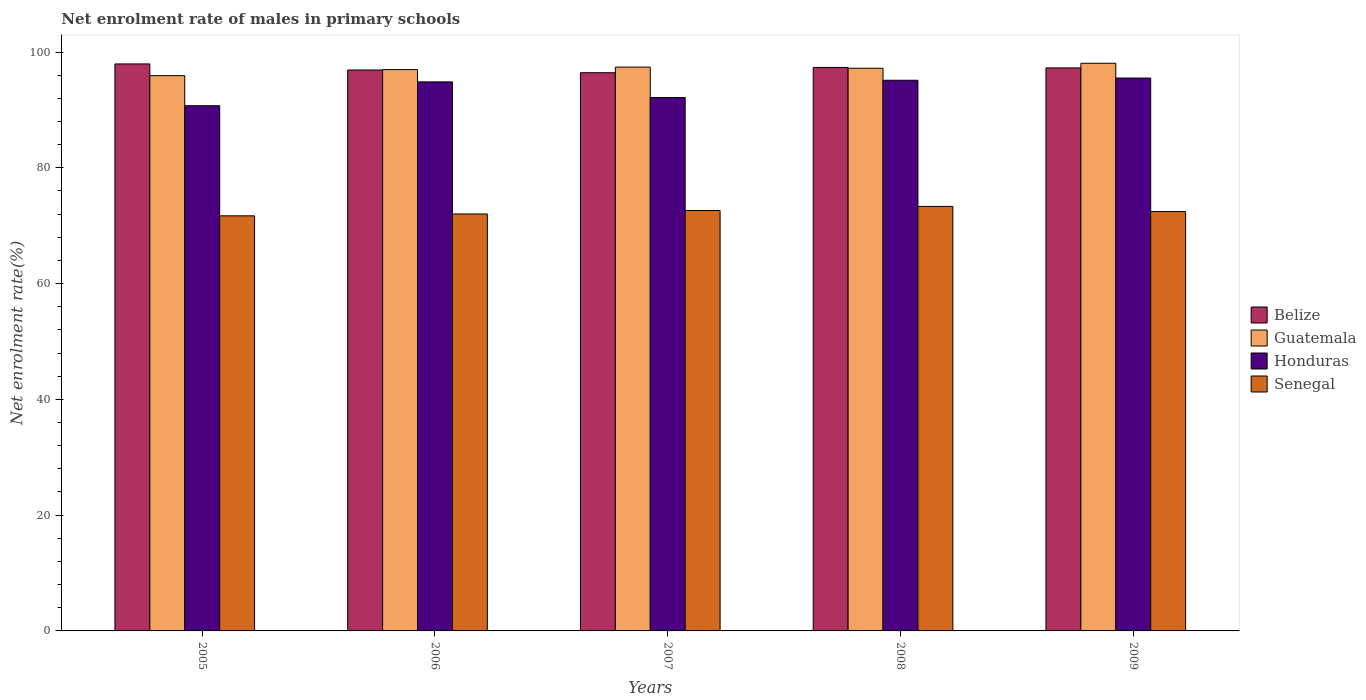How many bars are there on the 5th tick from the left?
Provide a succinct answer. 4. How many bars are there on the 5th tick from the right?
Ensure brevity in your answer.  4. What is the label of the 3rd group of bars from the left?
Your response must be concise. 2007. In how many cases, is the number of bars for a given year not equal to the number of legend labels?
Your response must be concise. 0. What is the net enrolment rate of males in primary schools in Belize in 2008?
Your answer should be very brief. 97.34. Across all years, what is the maximum net enrolment rate of males in primary schools in Belize?
Keep it short and to the point. 97.95. Across all years, what is the minimum net enrolment rate of males in primary schools in Belize?
Your answer should be compact. 96.43. In which year was the net enrolment rate of males in primary schools in Honduras maximum?
Make the answer very short. 2009. In which year was the net enrolment rate of males in primary schools in Honduras minimum?
Offer a very short reply. 2005. What is the total net enrolment rate of males in primary schools in Guatemala in the graph?
Offer a very short reply. 485.57. What is the difference between the net enrolment rate of males in primary schools in Guatemala in 2005 and that in 2006?
Provide a succinct answer. -1.05. What is the difference between the net enrolment rate of males in primary schools in Senegal in 2005 and the net enrolment rate of males in primary schools in Honduras in 2009?
Offer a terse response. -23.8. What is the average net enrolment rate of males in primary schools in Belize per year?
Give a very brief answer. 97.18. In the year 2007, what is the difference between the net enrolment rate of males in primary schools in Senegal and net enrolment rate of males in primary schools in Belize?
Your response must be concise. -23.8. What is the ratio of the net enrolment rate of males in primary schools in Honduras in 2006 to that in 2008?
Give a very brief answer. 1. What is the difference between the highest and the second highest net enrolment rate of males in primary schools in Honduras?
Provide a succinct answer. 0.38. What is the difference between the highest and the lowest net enrolment rate of males in primary schools in Guatemala?
Your response must be concise. 2.14. What does the 2nd bar from the left in 2005 represents?
Your answer should be very brief. Guatemala. What does the 1st bar from the right in 2005 represents?
Your answer should be compact. Senegal. How many bars are there?
Make the answer very short. 20. Are all the bars in the graph horizontal?
Offer a terse response. No. How many years are there in the graph?
Provide a succinct answer. 5. What is the difference between two consecutive major ticks on the Y-axis?
Provide a succinct answer. 20. Does the graph contain any zero values?
Give a very brief answer. No. Does the graph contain grids?
Keep it short and to the point. No. Where does the legend appear in the graph?
Give a very brief answer. Center right. How are the legend labels stacked?
Offer a terse response. Vertical. What is the title of the graph?
Offer a very short reply. Net enrolment rate of males in primary schools. What is the label or title of the X-axis?
Your answer should be compact. Years. What is the label or title of the Y-axis?
Provide a short and direct response. Net enrolment rate(%). What is the Net enrolment rate(%) in Belize in 2005?
Your answer should be compact. 97.95. What is the Net enrolment rate(%) in Guatemala in 2005?
Your answer should be compact. 95.92. What is the Net enrolment rate(%) in Honduras in 2005?
Provide a succinct answer. 90.73. What is the Net enrolment rate(%) of Senegal in 2005?
Give a very brief answer. 71.71. What is the Net enrolment rate(%) of Belize in 2006?
Ensure brevity in your answer.  96.9. What is the Net enrolment rate(%) of Guatemala in 2006?
Your response must be concise. 96.97. What is the Net enrolment rate(%) in Honduras in 2006?
Offer a very short reply. 94.85. What is the Net enrolment rate(%) of Senegal in 2006?
Your response must be concise. 72.03. What is the Net enrolment rate(%) in Belize in 2007?
Your response must be concise. 96.43. What is the Net enrolment rate(%) in Guatemala in 2007?
Offer a very short reply. 97.4. What is the Net enrolment rate(%) in Honduras in 2007?
Keep it short and to the point. 92.14. What is the Net enrolment rate(%) of Senegal in 2007?
Ensure brevity in your answer.  72.63. What is the Net enrolment rate(%) of Belize in 2008?
Ensure brevity in your answer.  97.34. What is the Net enrolment rate(%) in Guatemala in 2008?
Make the answer very short. 97.21. What is the Net enrolment rate(%) in Honduras in 2008?
Your answer should be very brief. 95.13. What is the Net enrolment rate(%) of Senegal in 2008?
Ensure brevity in your answer.  73.33. What is the Net enrolment rate(%) in Belize in 2009?
Your response must be concise. 97.26. What is the Net enrolment rate(%) in Guatemala in 2009?
Provide a short and direct response. 98.07. What is the Net enrolment rate(%) in Honduras in 2009?
Your answer should be very brief. 95.51. What is the Net enrolment rate(%) in Senegal in 2009?
Keep it short and to the point. 72.45. Across all years, what is the maximum Net enrolment rate(%) in Belize?
Offer a terse response. 97.95. Across all years, what is the maximum Net enrolment rate(%) in Guatemala?
Offer a very short reply. 98.07. Across all years, what is the maximum Net enrolment rate(%) in Honduras?
Your response must be concise. 95.51. Across all years, what is the maximum Net enrolment rate(%) in Senegal?
Make the answer very short. 73.33. Across all years, what is the minimum Net enrolment rate(%) of Belize?
Provide a short and direct response. 96.43. Across all years, what is the minimum Net enrolment rate(%) of Guatemala?
Provide a succinct answer. 95.92. Across all years, what is the minimum Net enrolment rate(%) in Honduras?
Your answer should be compact. 90.73. Across all years, what is the minimum Net enrolment rate(%) of Senegal?
Give a very brief answer. 71.71. What is the total Net enrolment rate(%) of Belize in the graph?
Your answer should be compact. 485.89. What is the total Net enrolment rate(%) of Guatemala in the graph?
Provide a short and direct response. 485.57. What is the total Net enrolment rate(%) of Honduras in the graph?
Your answer should be very brief. 468.37. What is the total Net enrolment rate(%) of Senegal in the graph?
Give a very brief answer. 362.15. What is the difference between the Net enrolment rate(%) in Belize in 2005 and that in 2006?
Ensure brevity in your answer.  1.05. What is the difference between the Net enrolment rate(%) of Guatemala in 2005 and that in 2006?
Keep it short and to the point. -1.05. What is the difference between the Net enrolment rate(%) in Honduras in 2005 and that in 2006?
Offer a terse response. -4.12. What is the difference between the Net enrolment rate(%) in Senegal in 2005 and that in 2006?
Provide a short and direct response. -0.32. What is the difference between the Net enrolment rate(%) of Belize in 2005 and that in 2007?
Keep it short and to the point. 1.52. What is the difference between the Net enrolment rate(%) in Guatemala in 2005 and that in 2007?
Your response must be concise. -1.48. What is the difference between the Net enrolment rate(%) in Honduras in 2005 and that in 2007?
Provide a succinct answer. -1.41. What is the difference between the Net enrolment rate(%) in Senegal in 2005 and that in 2007?
Ensure brevity in your answer.  -0.92. What is the difference between the Net enrolment rate(%) in Belize in 2005 and that in 2008?
Your response must be concise. 0.61. What is the difference between the Net enrolment rate(%) in Guatemala in 2005 and that in 2008?
Ensure brevity in your answer.  -1.28. What is the difference between the Net enrolment rate(%) in Honduras in 2005 and that in 2008?
Provide a succinct answer. -4.4. What is the difference between the Net enrolment rate(%) in Senegal in 2005 and that in 2008?
Offer a very short reply. -1.63. What is the difference between the Net enrolment rate(%) in Belize in 2005 and that in 2009?
Make the answer very short. 0.69. What is the difference between the Net enrolment rate(%) of Guatemala in 2005 and that in 2009?
Keep it short and to the point. -2.14. What is the difference between the Net enrolment rate(%) in Honduras in 2005 and that in 2009?
Your answer should be very brief. -4.78. What is the difference between the Net enrolment rate(%) of Senegal in 2005 and that in 2009?
Your answer should be compact. -0.74. What is the difference between the Net enrolment rate(%) of Belize in 2006 and that in 2007?
Offer a very short reply. 0.47. What is the difference between the Net enrolment rate(%) of Guatemala in 2006 and that in 2007?
Offer a very short reply. -0.43. What is the difference between the Net enrolment rate(%) of Honduras in 2006 and that in 2007?
Give a very brief answer. 2.71. What is the difference between the Net enrolment rate(%) of Senegal in 2006 and that in 2007?
Offer a terse response. -0.6. What is the difference between the Net enrolment rate(%) of Belize in 2006 and that in 2008?
Your response must be concise. -0.44. What is the difference between the Net enrolment rate(%) in Guatemala in 2006 and that in 2008?
Offer a very short reply. -0.24. What is the difference between the Net enrolment rate(%) in Honduras in 2006 and that in 2008?
Your answer should be very brief. -0.28. What is the difference between the Net enrolment rate(%) in Senegal in 2006 and that in 2008?
Provide a short and direct response. -1.3. What is the difference between the Net enrolment rate(%) of Belize in 2006 and that in 2009?
Ensure brevity in your answer.  -0.36. What is the difference between the Net enrolment rate(%) in Guatemala in 2006 and that in 2009?
Ensure brevity in your answer.  -1.1. What is the difference between the Net enrolment rate(%) in Honduras in 2006 and that in 2009?
Ensure brevity in your answer.  -0.66. What is the difference between the Net enrolment rate(%) of Senegal in 2006 and that in 2009?
Give a very brief answer. -0.42. What is the difference between the Net enrolment rate(%) of Belize in 2007 and that in 2008?
Offer a very short reply. -0.91. What is the difference between the Net enrolment rate(%) of Guatemala in 2007 and that in 2008?
Keep it short and to the point. 0.2. What is the difference between the Net enrolment rate(%) of Honduras in 2007 and that in 2008?
Ensure brevity in your answer.  -2.99. What is the difference between the Net enrolment rate(%) of Senegal in 2007 and that in 2008?
Ensure brevity in your answer.  -0.71. What is the difference between the Net enrolment rate(%) of Belize in 2007 and that in 2009?
Keep it short and to the point. -0.83. What is the difference between the Net enrolment rate(%) in Guatemala in 2007 and that in 2009?
Offer a very short reply. -0.66. What is the difference between the Net enrolment rate(%) of Honduras in 2007 and that in 2009?
Give a very brief answer. -3.37. What is the difference between the Net enrolment rate(%) in Senegal in 2007 and that in 2009?
Your answer should be very brief. 0.18. What is the difference between the Net enrolment rate(%) of Belize in 2008 and that in 2009?
Your response must be concise. 0.08. What is the difference between the Net enrolment rate(%) of Guatemala in 2008 and that in 2009?
Make the answer very short. -0.86. What is the difference between the Net enrolment rate(%) in Honduras in 2008 and that in 2009?
Keep it short and to the point. -0.38. What is the difference between the Net enrolment rate(%) of Senegal in 2008 and that in 2009?
Your answer should be very brief. 0.89. What is the difference between the Net enrolment rate(%) in Belize in 2005 and the Net enrolment rate(%) in Guatemala in 2006?
Offer a terse response. 0.98. What is the difference between the Net enrolment rate(%) of Belize in 2005 and the Net enrolment rate(%) of Honduras in 2006?
Offer a very short reply. 3.1. What is the difference between the Net enrolment rate(%) in Belize in 2005 and the Net enrolment rate(%) in Senegal in 2006?
Make the answer very short. 25.92. What is the difference between the Net enrolment rate(%) of Guatemala in 2005 and the Net enrolment rate(%) of Honduras in 2006?
Keep it short and to the point. 1.07. What is the difference between the Net enrolment rate(%) in Guatemala in 2005 and the Net enrolment rate(%) in Senegal in 2006?
Ensure brevity in your answer.  23.89. What is the difference between the Net enrolment rate(%) in Honduras in 2005 and the Net enrolment rate(%) in Senegal in 2006?
Ensure brevity in your answer.  18.7. What is the difference between the Net enrolment rate(%) of Belize in 2005 and the Net enrolment rate(%) of Guatemala in 2007?
Give a very brief answer. 0.55. What is the difference between the Net enrolment rate(%) in Belize in 2005 and the Net enrolment rate(%) in Honduras in 2007?
Ensure brevity in your answer.  5.81. What is the difference between the Net enrolment rate(%) of Belize in 2005 and the Net enrolment rate(%) of Senegal in 2007?
Make the answer very short. 25.32. What is the difference between the Net enrolment rate(%) in Guatemala in 2005 and the Net enrolment rate(%) in Honduras in 2007?
Provide a succinct answer. 3.78. What is the difference between the Net enrolment rate(%) in Guatemala in 2005 and the Net enrolment rate(%) in Senegal in 2007?
Your response must be concise. 23.3. What is the difference between the Net enrolment rate(%) in Honduras in 2005 and the Net enrolment rate(%) in Senegal in 2007?
Provide a short and direct response. 18.1. What is the difference between the Net enrolment rate(%) in Belize in 2005 and the Net enrolment rate(%) in Guatemala in 2008?
Provide a short and direct response. 0.74. What is the difference between the Net enrolment rate(%) in Belize in 2005 and the Net enrolment rate(%) in Honduras in 2008?
Provide a succinct answer. 2.82. What is the difference between the Net enrolment rate(%) in Belize in 2005 and the Net enrolment rate(%) in Senegal in 2008?
Your answer should be compact. 24.62. What is the difference between the Net enrolment rate(%) in Guatemala in 2005 and the Net enrolment rate(%) in Honduras in 2008?
Provide a short and direct response. 0.79. What is the difference between the Net enrolment rate(%) of Guatemala in 2005 and the Net enrolment rate(%) of Senegal in 2008?
Make the answer very short. 22.59. What is the difference between the Net enrolment rate(%) of Honduras in 2005 and the Net enrolment rate(%) of Senegal in 2008?
Provide a short and direct response. 17.4. What is the difference between the Net enrolment rate(%) in Belize in 2005 and the Net enrolment rate(%) in Guatemala in 2009?
Offer a very short reply. -0.12. What is the difference between the Net enrolment rate(%) of Belize in 2005 and the Net enrolment rate(%) of Honduras in 2009?
Your answer should be compact. 2.44. What is the difference between the Net enrolment rate(%) in Belize in 2005 and the Net enrolment rate(%) in Senegal in 2009?
Make the answer very short. 25.5. What is the difference between the Net enrolment rate(%) of Guatemala in 2005 and the Net enrolment rate(%) of Honduras in 2009?
Your response must be concise. 0.41. What is the difference between the Net enrolment rate(%) in Guatemala in 2005 and the Net enrolment rate(%) in Senegal in 2009?
Offer a very short reply. 23.48. What is the difference between the Net enrolment rate(%) of Honduras in 2005 and the Net enrolment rate(%) of Senegal in 2009?
Offer a terse response. 18.28. What is the difference between the Net enrolment rate(%) in Belize in 2006 and the Net enrolment rate(%) in Guatemala in 2007?
Offer a terse response. -0.5. What is the difference between the Net enrolment rate(%) in Belize in 2006 and the Net enrolment rate(%) in Honduras in 2007?
Ensure brevity in your answer.  4.76. What is the difference between the Net enrolment rate(%) in Belize in 2006 and the Net enrolment rate(%) in Senegal in 2007?
Your response must be concise. 24.27. What is the difference between the Net enrolment rate(%) in Guatemala in 2006 and the Net enrolment rate(%) in Honduras in 2007?
Ensure brevity in your answer.  4.83. What is the difference between the Net enrolment rate(%) of Guatemala in 2006 and the Net enrolment rate(%) of Senegal in 2007?
Keep it short and to the point. 24.34. What is the difference between the Net enrolment rate(%) of Honduras in 2006 and the Net enrolment rate(%) of Senegal in 2007?
Provide a short and direct response. 22.22. What is the difference between the Net enrolment rate(%) of Belize in 2006 and the Net enrolment rate(%) of Guatemala in 2008?
Offer a very short reply. -0.31. What is the difference between the Net enrolment rate(%) of Belize in 2006 and the Net enrolment rate(%) of Honduras in 2008?
Provide a succinct answer. 1.77. What is the difference between the Net enrolment rate(%) in Belize in 2006 and the Net enrolment rate(%) in Senegal in 2008?
Offer a terse response. 23.57. What is the difference between the Net enrolment rate(%) in Guatemala in 2006 and the Net enrolment rate(%) in Honduras in 2008?
Provide a short and direct response. 1.84. What is the difference between the Net enrolment rate(%) in Guatemala in 2006 and the Net enrolment rate(%) in Senegal in 2008?
Make the answer very short. 23.64. What is the difference between the Net enrolment rate(%) in Honduras in 2006 and the Net enrolment rate(%) in Senegal in 2008?
Ensure brevity in your answer.  21.52. What is the difference between the Net enrolment rate(%) of Belize in 2006 and the Net enrolment rate(%) of Guatemala in 2009?
Keep it short and to the point. -1.17. What is the difference between the Net enrolment rate(%) in Belize in 2006 and the Net enrolment rate(%) in Honduras in 2009?
Make the answer very short. 1.39. What is the difference between the Net enrolment rate(%) of Belize in 2006 and the Net enrolment rate(%) of Senegal in 2009?
Give a very brief answer. 24.45. What is the difference between the Net enrolment rate(%) in Guatemala in 2006 and the Net enrolment rate(%) in Honduras in 2009?
Provide a succinct answer. 1.46. What is the difference between the Net enrolment rate(%) of Guatemala in 2006 and the Net enrolment rate(%) of Senegal in 2009?
Your answer should be very brief. 24.52. What is the difference between the Net enrolment rate(%) in Honduras in 2006 and the Net enrolment rate(%) in Senegal in 2009?
Make the answer very short. 22.41. What is the difference between the Net enrolment rate(%) of Belize in 2007 and the Net enrolment rate(%) of Guatemala in 2008?
Make the answer very short. -0.77. What is the difference between the Net enrolment rate(%) of Belize in 2007 and the Net enrolment rate(%) of Honduras in 2008?
Ensure brevity in your answer.  1.3. What is the difference between the Net enrolment rate(%) in Belize in 2007 and the Net enrolment rate(%) in Senegal in 2008?
Offer a very short reply. 23.1. What is the difference between the Net enrolment rate(%) in Guatemala in 2007 and the Net enrolment rate(%) in Honduras in 2008?
Give a very brief answer. 2.27. What is the difference between the Net enrolment rate(%) of Guatemala in 2007 and the Net enrolment rate(%) of Senegal in 2008?
Provide a short and direct response. 24.07. What is the difference between the Net enrolment rate(%) of Honduras in 2007 and the Net enrolment rate(%) of Senegal in 2008?
Make the answer very short. 18.81. What is the difference between the Net enrolment rate(%) in Belize in 2007 and the Net enrolment rate(%) in Guatemala in 2009?
Your answer should be very brief. -1.63. What is the difference between the Net enrolment rate(%) of Belize in 2007 and the Net enrolment rate(%) of Honduras in 2009?
Offer a terse response. 0.92. What is the difference between the Net enrolment rate(%) of Belize in 2007 and the Net enrolment rate(%) of Senegal in 2009?
Offer a terse response. 23.99. What is the difference between the Net enrolment rate(%) in Guatemala in 2007 and the Net enrolment rate(%) in Honduras in 2009?
Your answer should be very brief. 1.89. What is the difference between the Net enrolment rate(%) in Guatemala in 2007 and the Net enrolment rate(%) in Senegal in 2009?
Your answer should be very brief. 24.96. What is the difference between the Net enrolment rate(%) of Honduras in 2007 and the Net enrolment rate(%) of Senegal in 2009?
Your answer should be compact. 19.7. What is the difference between the Net enrolment rate(%) in Belize in 2008 and the Net enrolment rate(%) in Guatemala in 2009?
Give a very brief answer. -0.72. What is the difference between the Net enrolment rate(%) in Belize in 2008 and the Net enrolment rate(%) in Honduras in 2009?
Make the answer very short. 1.83. What is the difference between the Net enrolment rate(%) in Belize in 2008 and the Net enrolment rate(%) in Senegal in 2009?
Offer a very short reply. 24.9. What is the difference between the Net enrolment rate(%) of Guatemala in 2008 and the Net enrolment rate(%) of Honduras in 2009?
Provide a short and direct response. 1.69. What is the difference between the Net enrolment rate(%) of Guatemala in 2008 and the Net enrolment rate(%) of Senegal in 2009?
Make the answer very short. 24.76. What is the difference between the Net enrolment rate(%) in Honduras in 2008 and the Net enrolment rate(%) in Senegal in 2009?
Your answer should be very brief. 22.68. What is the average Net enrolment rate(%) of Belize per year?
Keep it short and to the point. 97.18. What is the average Net enrolment rate(%) in Guatemala per year?
Offer a terse response. 97.11. What is the average Net enrolment rate(%) in Honduras per year?
Make the answer very short. 93.67. What is the average Net enrolment rate(%) in Senegal per year?
Give a very brief answer. 72.43. In the year 2005, what is the difference between the Net enrolment rate(%) of Belize and Net enrolment rate(%) of Guatemala?
Offer a terse response. 2.03. In the year 2005, what is the difference between the Net enrolment rate(%) of Belize and Net enrolment rate(%) of Honduras?
Provide a short and direct response. 7.22. In the year 2005, what is the difference between the Net enrolment rate(%) of Belize and Net enrolment rate(%) of Senegal?
Keep it short and to the point. 26.24. In the year 2005, what is the difference between the Net enrolment rate(%) in Guatemala and Net enrolment rate(%) in Honduras?
Your answer should be very brief. 5.19. In the year 2005, what is the difference between the Net enrolment rate(%) in Guatemala and Net enrolment rate(%) in Senegal?
Your answer should be compact. 24.21. In the year 2005, what is the difference between the Net enrolment rate(%) in Honduras and Net enrolment rate(%) in Senegal?
Provide a succinct answer. 19.02. In the year 2006, what is the difference between the Net enrolment rate(%) of Belize and Net enrolment rate(%) of Guatemala?
Offer a terse response. -0.07. In the year 2006, what is the difference between the Net enrolment rate(%) in Belize and Net enrolment rate(%) in Honduras?
Your response must be concise. 2.05. In the year 2006, what is the difference between the Net enrolment rate(%) of Belize and Net enrolment rate(%) of Senegal?
Your answer should be compact. 24.87. In the year 2006, what is the difference between the Net enrolment rate(%) of Guatemala and Net enrolment rate(%) of Honduras?
Make the answer very short. 2.12. In the year 2006, what is the difference between the Net enrolment rate(%) in Guatemala and Net enrolment rate(%) in Senegal?
Offer a terse response. 24.94. In the year 2006, what is the difference between the Net enrolment rate(%) in Honduras and Net enrolment rate(%) in Senegal?
Your response must be concise. 22.82. In the year 2007, what is the difference between the Net enrolment rate(%) of Belize and Net enrolment rate(%) of Guatemala?
Make the answer very short. -0.97. In the year 2007, what is the difference between the Net enrolment rate(%) of Belize and Net enrolment rate(%) of Honduras?
Your answer should be compact. 4.29. In the year 2007, what is the difference between the Net enrolment rate(%) in Belize and Net enrolment rate(%) in Senegal?
Offer a terse response. 23.8. In the year 2007, what is the difference between the Net enrolment rate(%) of Guatemala and Net enrolment rate(%) of Honduras?
Ensure brevity in your answer.  5.26. In the year 2007, what is the difference between the Net enrolment rate(%) of Guatemala and Net enrolment rate(%) of Senegal?
Your answer should be very brief. 24.77. In the year 2007, what is the difference between the Net enrolment rate(%) in Honduras and Net enrolment rate(%) in Senegal?
Provide a short and direct response. 19.51. In the year 2008, what is the difference between the Net enrolment rate(%) in Belize and Net enrolment rate(%) in Guatemala?
Your answer should be compact. 0.14. In the year 2008, what is the difference between the Net enrolment rate(%) in Belize and Net enrolment rate(%) in Honduras?
Ensure brevity in your answer.  2.21. In the year 2008, what is the difference between the Net enrolment rate(%) of Belize and Net enrolment rate(%) of Senegal?
Provide a short and direct response. 24.01. In the year 2008, what is the difference between the Net enrolment rate(%) in Guatemala and Net enrolment rate(%) in Honduras?
Your response must be concise. 2.08. In the year 2008, what is the difference between the Net enrolment rate(%) in Guatemala and Net enrolment rate(%) in Senegal?
Keep it short and to the point. 23.87. In the year 2008, what is the difference between the Net enrolment rate(%) of Honduras and Net enrolment rate(%) of Senegal?
Provide a succinct answer. 21.8. In the year 2009, what is the difference between the Net enrolment rate(%) in Belize and Net enrolment rate(%) in Guatemala?
Make the answer very short. -0.8. In the year 2009, what is the difference between the Net enrolment rate(%) of Belize and Net enrolment rate(%) of Honduras?
Provide a short and direct response. 1.75. In the year 2009, what is the difference between the Net enrolment rate(%) of Belize and Net enrolment rate(%) of Senegal?
Offer a very short reply. 24.82. In the year 2009, what is the difference between the Net enrolment rate(%) in Guatemala and Net enrolment rate(%) in Honduras?
Provide a short and direct response. 2.55. In the year 2009, what is the difference between the Net enrolment rate(%) in Guatemala and Net enrolment rate(%) in Senegal?
Provide a succinct answer. 25.62. In the year 2009, what is the difference between the Net enrolment rate(%) in Honduras and Net enrolment rate(%) in Senegal?
Offer a very short reply. 23.07. What is the ratio of the Net enrolment rate(%) in Belize in 2005 to that in 2006?
Your response must be concise. 1.01. What is the ratio of the Net enrolment rate(%) in Honduras in 2005 to that in 2006?
Provide a short and direct response. 0.96. What is the ratio of the Net enrolment rate(%) of Senegal in 2005 to that in 2006?
Your response must be concise. 1. What is the ratio of the Net enrolment rate(%) in Belize in 2005 to that in 2007?
Keep it short and to the point. 1.02. What is the ratio of the Net enrolment rate(%) of Honduras in 2005 to that in 2007?
Offer a terse response. 0.98. What is the ratio of the Net enrolment rate(%) in Senegal in 2005 to that in 2007?
Your answer should be compact. 0.99. What is the ratio of the Net enrolment rate(%) in Belize in 2005 to that in 2008?
Ensure brevity in your answer.  1.01. What is the ratio of the Net enrolment rate(%) in Honduras in 2005 to that in 2008?
Offer a very short reply. 0.95. What is the ratio of the Net enrolment rate(%) in Senegal in 2005 to that in 2008?
Your response must be concise. 0.98. What is the ratio of the Net enrolment rate(%) in Belize in 2005 to that in 2009?
Make the answer very short. 1.01. What is the ratio of the Net enrolment rate(%) of Guatemala in 2005 to that in 2009?
Offer a terse response. 0.98. What is the ratio of the Net enrolment rate(%) of Honduras in 2005 to that in 2009?
Provide a succinct answer. 0.95. What is the ratio of the Net enrolment rate(%) of Belize in 2006 to that in 2007?
Make the answer very short. 1. What is the ratio of the Net enrolment rate(%) in Guatemala in 2006 to that in 2007?
Your answer should be compact. 1. What is the ratio of the Net enrolment rate(%) of Honduras in 2006 to that in 2007?
Offer a very short reply. 1.03. What is the ratio of the Net enrolment rate(%) in Senegal in 2006 to that in 2007?
Offer a very short reply. 0.99. What is the ratio of the Net enrolment rate(%) in Belize in 2006 to that in 2008?
Ensure brevity in your answer.  1. What is the ratio of the Net enrolment rate(%) in Guatemala in 2006 to that in 2008?
Offer a very short reply. 1. What is the ratio of the Net enrolment rate(%) of Senegal in 2006 to that in 2008?
Provide a short and direct response. 0.98. What is the ratio of the Net enrolment rate(%) of Belize in 2006 to that in 2009?
Your response must be concise. 1. What is the ratio of the Net enrolment rate(%) of Honduras in 2006 to that in 2009?
Offer a terse response. 0.99. What is the ratio of the Net enrolment rate(%) of Belize in 2007 to that in 2008?
Ensure brevity in your answer.  0.99. What is the ratio of the Net enrolment rate(%) in Honduras in 2007 to that in 2008?
Give a very brief answer. 0.97. What is the ratio of the Net enrolment rate(%) in Senegal in 2007 to that in 2008?
Your answer should be very brief. 0.99. What is the ratio of the Net enrolment rate(%) in Guatemala in 2007 to that in 2009?
Your answer should be very brief. 0.99. What is the ratio of the Net enrolment rate(%) of Honduras in 2007 to that in 2009?
Offer a very short reply. 0.96. What is the ratio of the Net enrolment rate(%) of Belize in 2008 to that in 2009?
Ensure brevity in your answer.  1. What is the ratio of the Net enrolment rate(%) of Honduras in 2008 to that in 2009?
Provide a short and direct response. 1. What is the ratio of the Net enrolment rate(%) in Senegal in 2008 to that in 2009?
Make the answer very short. 1.01. What is the difference between the highest and the second highest Net enrolment rate(%) of Belize?
Provide a short and direct response. 0.61. What is the difference between the highest and the second highest Net enrolment rate(%) of Guatemala?
Offer a terse response. 0.66. What is the difference between the highest and the second highest Net enrolment rate(%) in Honduras?
Give a very brief answer. 0.38. What is the difference between the highest and the second highest Net enrolment rate(%) of Senegal?
Offer a very short reply. 0.71. What is the difference between the highest and the lowest Net enrolment rate(%) in Belize?
Your response must be concise. 1.52. What is the difference between the highest and the lowest Net enrolment rate(%) of Guatemala?
Your answer should be compact. 2.14. What is the difference between the highest and the lowest Net enrolment rate(%) of Honduras?
Offer a terse response. 4.78. What is the difference between the highest and the lowest Net enrolment rate(%) in Senegal?
Offer a very short reply. 1.63. 